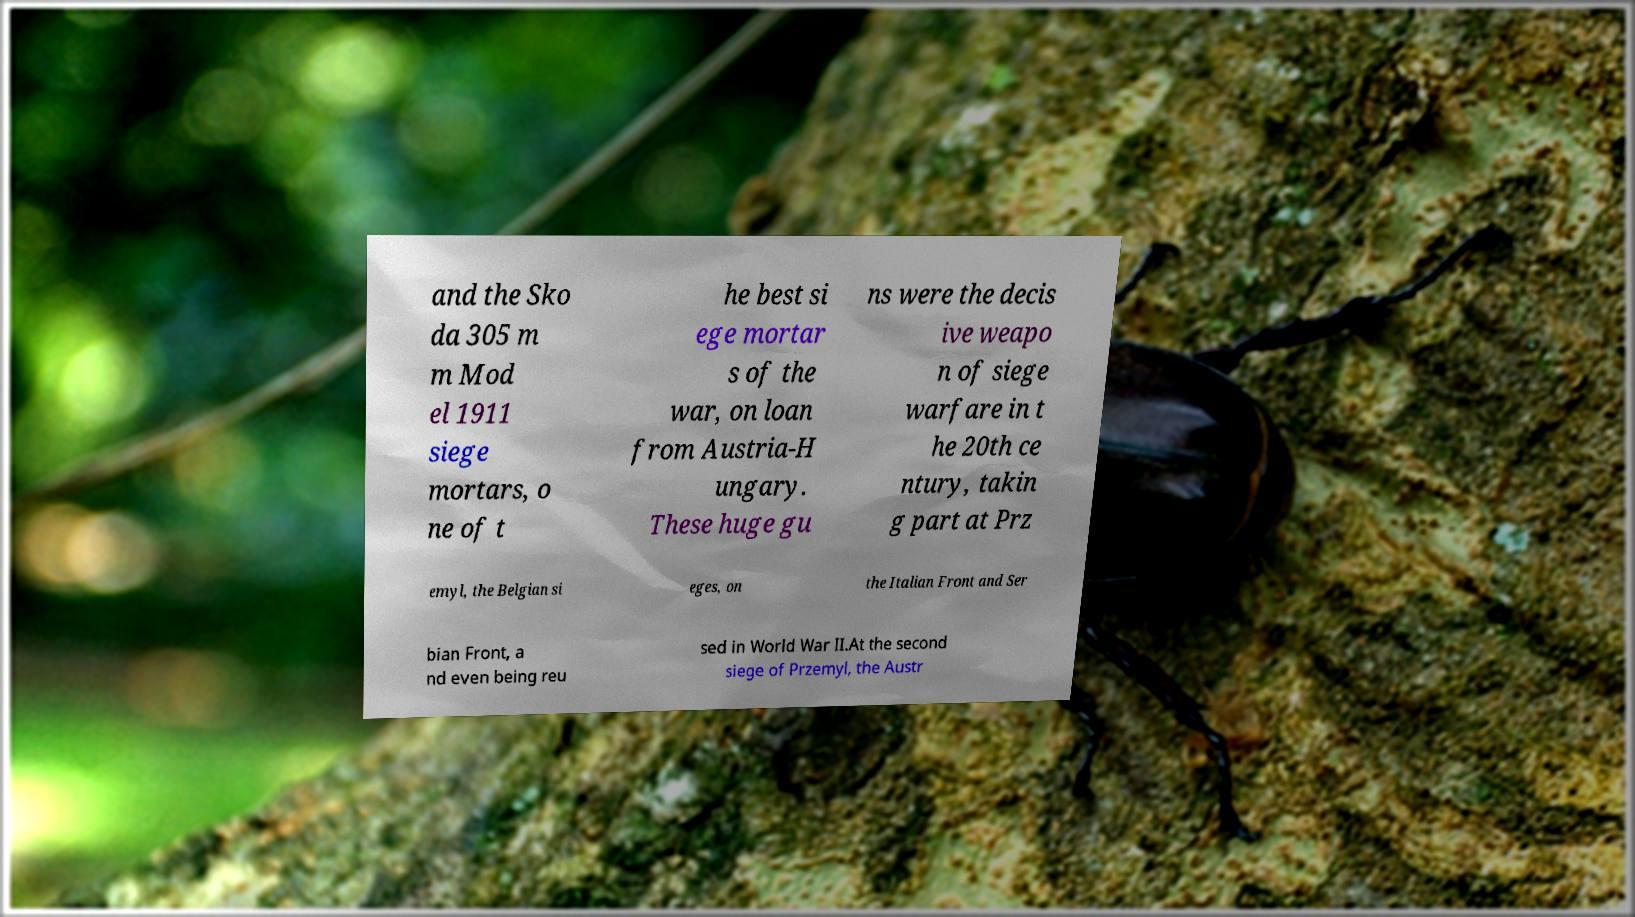Can you accurately transcribe the text from the provided image for me? and the Sko da 305 m m Mod el 1911 siege mortars, o ne of t he best si ege mortar s of the war, on loan from Austria-H ungary. These huge gu ns were the decis ive weapo n of siege warfare in t he 20th ce ntury, takin g part at Prz emyl, the Belgian si eges, on the Italian Front and Ser bian Front, a nd even being reu sed in World War II.At the second siege of Przemyl, the Austr 